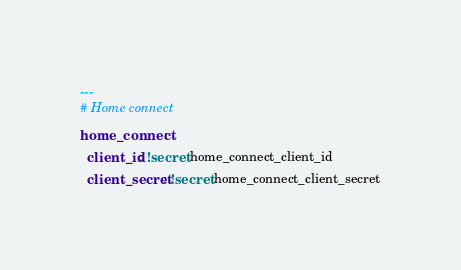Convert code to text. <code><loc_0><loc_0><loc_500><loc_500><_YAML_>---
# Home connect
home_connect:
  client_id: !secret home_connect_client_id
  client_secret: !secret home_connect_client_secret
</code> 